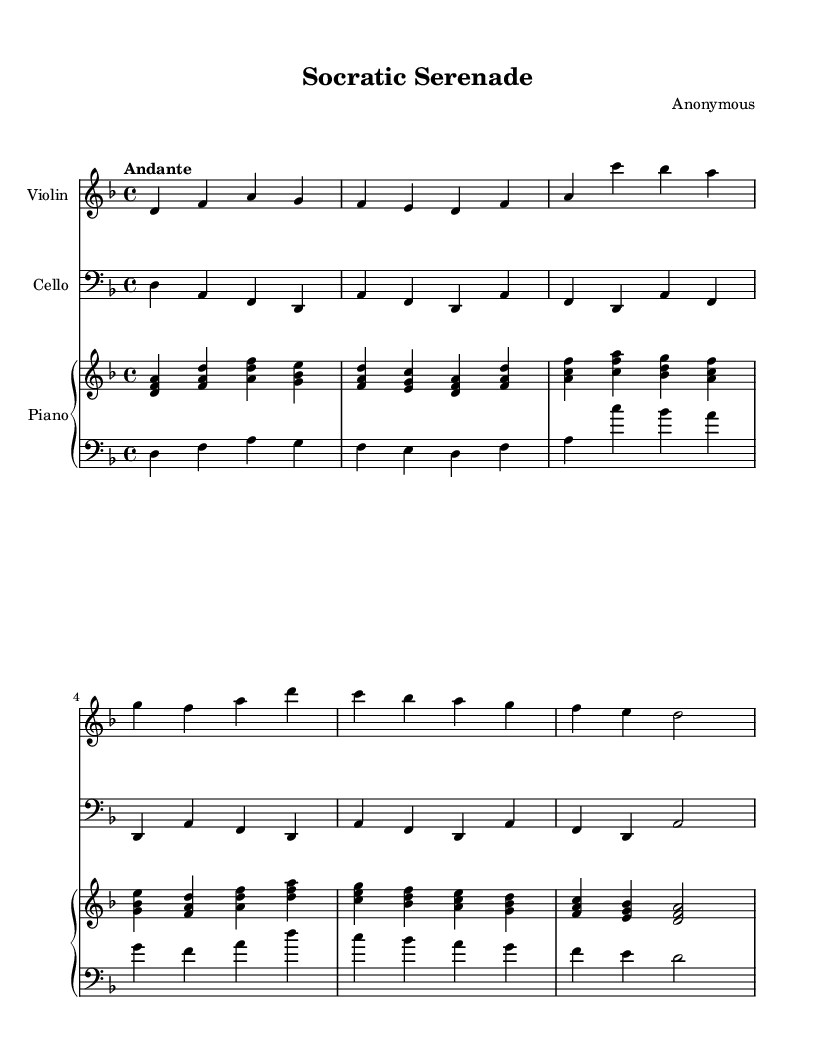What is the key signature of this music? The key signature is indicated by the presence of one flat, which identifies D minor.
Answer: D minor What is the time signature of this music? The time signature is located at the beginning of the piece, shown as a fraction with a “4” on top and another “4” on the bottom, which represents four beats per measure.
Answer: 4/4 What tempo marking is indicated in this piece? The tempo is stated at the beginning of the score as "Andante," which means a moderately slow tempo.
Answer: Andante What instruments are included in this composition? The instruments can be identified by their respective staff labels; the music includes a Violin, Cello, and Piano.
Answer: Violin, Cello, Piano How many measures are presented in the Violin part? Counting the vertical lines separating the measures in the Violin staff, there are a total of six measures.
Answer: 6 Which philosophical theme does the title "Socratic Serenade" imply? The title suggests a connection to Socratic philosophy, which emphasizes dialogue and questioning as a means of understanding, indicating the music may reflect these themes.
Answer: Socratic philosophy What is the final note in the Cello part? The Cello part ends on the note D, which is indicated at the beginning of the last measure.
Answer: D 